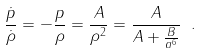Convert formula to latex. <formula><loc_0><loc_0><loc_500><loc_500>\frac { \dot { p } } { \dot { \rho } } = - \frac { p } { \rho } = \frac { A } { \rho ^ { 2 } } = \frac { A } { A + \frac { B } { a ^ { 6 } } } \ .</formula> 